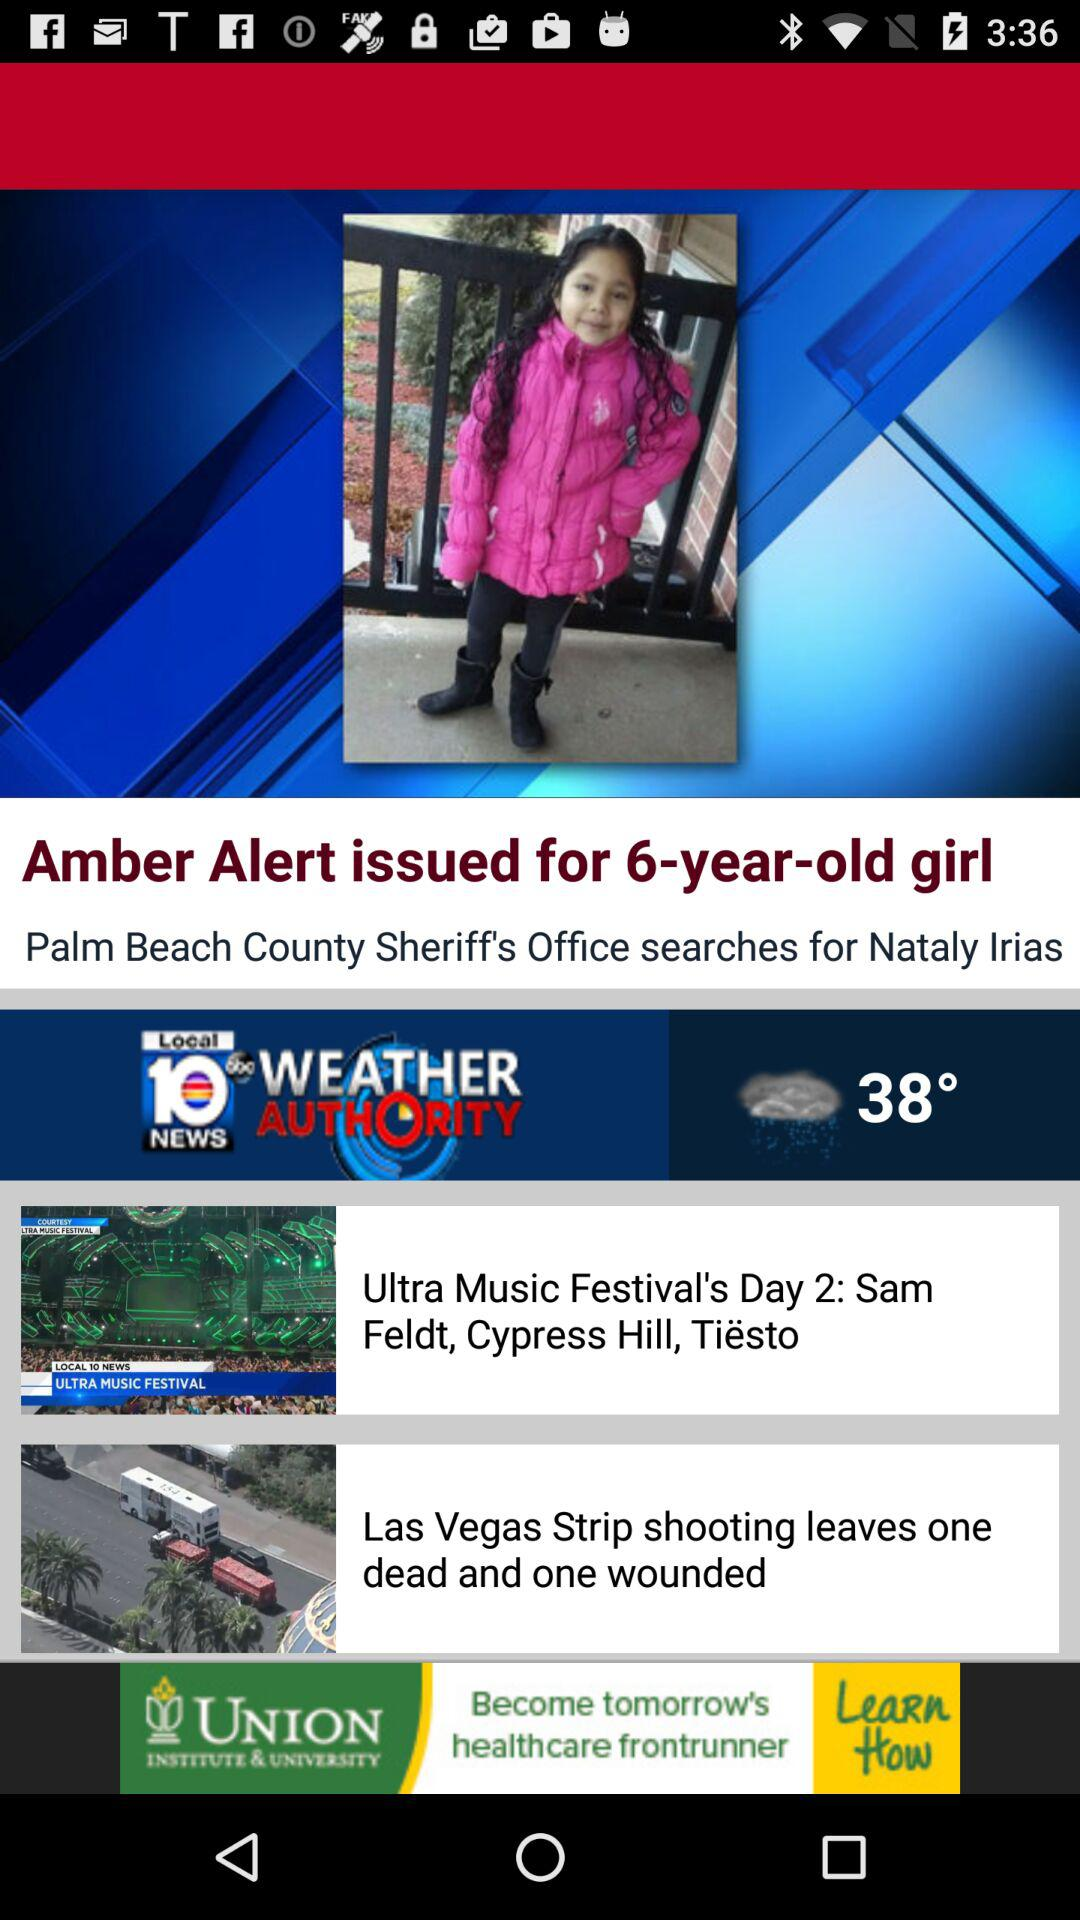What is the age of the girl? The girl is 6 years old. 